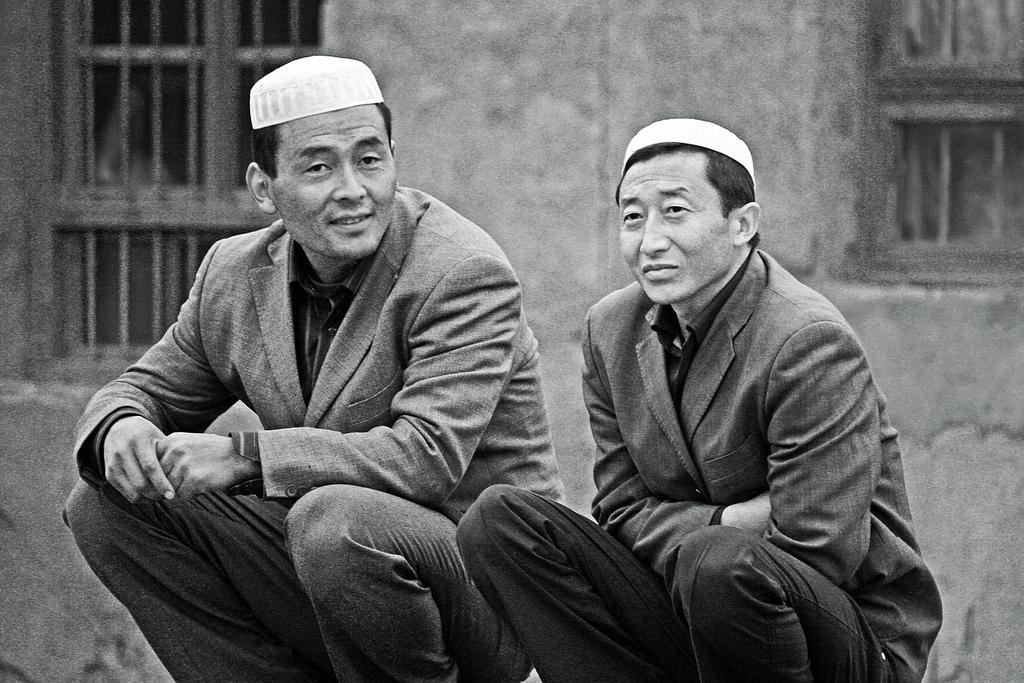How many men are present in the image? There are two men in the image. What are the men wearing on their upper bodies? Both men are wearing coats. What type of headwear are the men wearing? Both men are wearing caps on their heads. What can be seen in the background of the image? There are windows and a wall in the background of the image. What type of plastic material can be seen in the image? There is no plastic material present in the image. Can you tell me how many pears are visible in the image? There are no pears present in the image. 